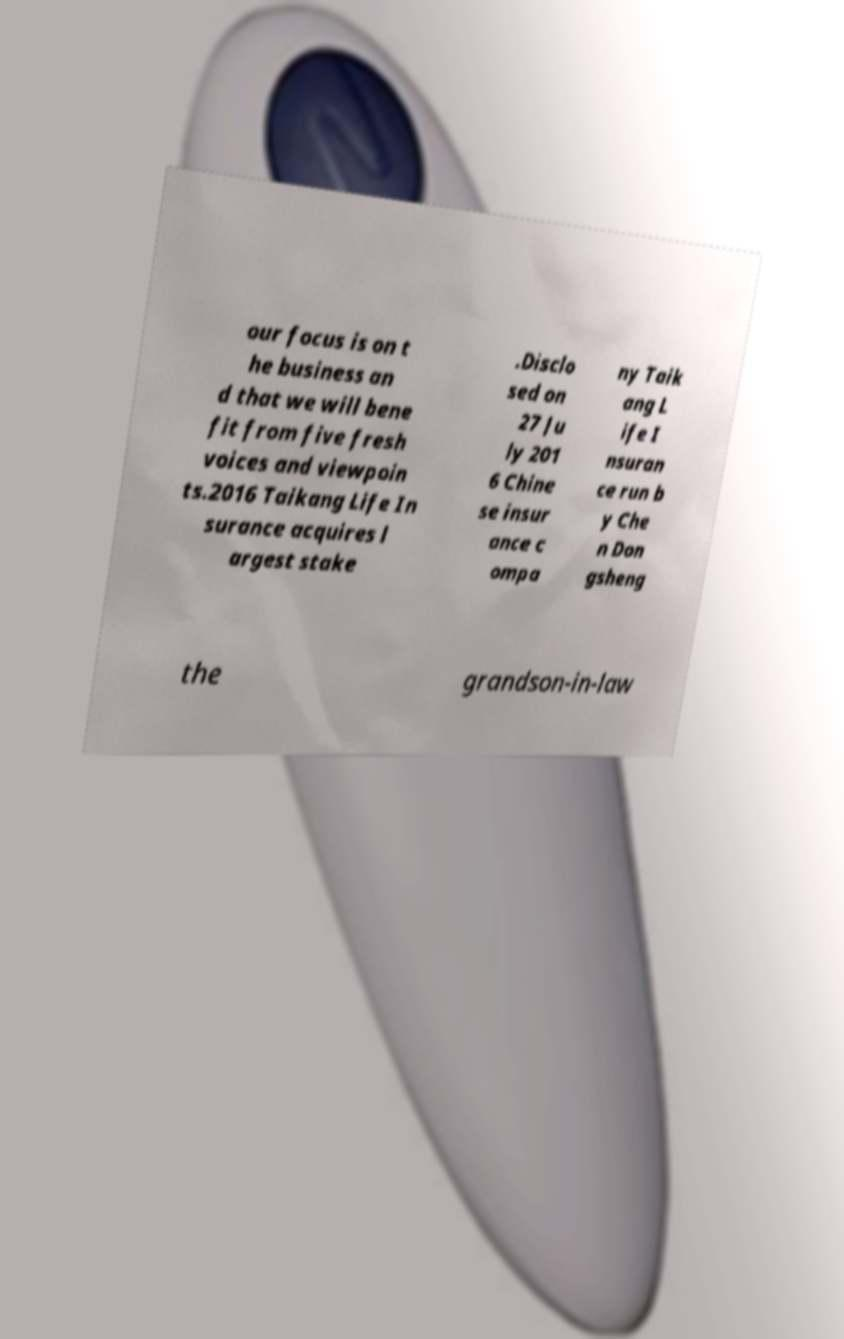Could you extract and type out the text from this image? our focus is on t he business an d that we will bene fit from five fresh voices and viewpoin ts.2016 Taikang Life In surance acquires l argest stake .Disclo sed on 27 Ju ly 201 6 Chine se insur ance c ompa ny Taik ang L ife I nsuran ce run b y Che n Don gsheng the grandson-in-law 